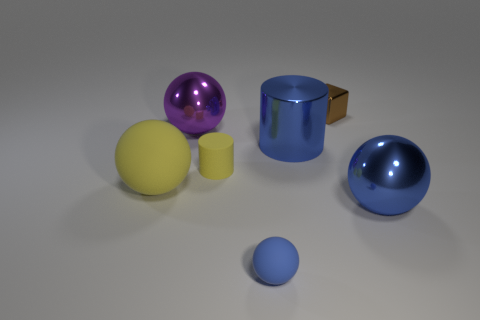Is the material of the small brown cube the same as the blue cylinder?
Keep it short and to the point. Yes. Are there any yellow balls that have the same size as the blue metallic cylinder?
Provide a short and direct response. Yes. There is a cylinder that is the same size as the purple object; what is it made of?
Keep it short and to the point. Metal. Are there any blue metallic objects of the same shape as the brown thing?
Offer a very short reply. No. What material is the thing that is the same color as the small matte cylinder?
Provide a short and direct response. Rubber. There is a blue shiny thing that is in front of the blue cylinder; what is its shape?
Keep it short and to the point. Sphere. What number of tiny gray metal objects are there?
Your response must be concise. 0. There is a tiny block that is made of the same material as the big purple object; what color is it?
Keep it short and to the point. Brown. What number of large things are purple rubber cubes or cylinders?
Provide a short and direct response. 1. There is a small blue sphere; how many brown metal cubes are behind it?
Provide a short and direct response. 1. 